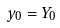<formula> <loc_0><loc_0><loc_500><loc_500>y _ { 0 } = Y _ { 0 }</formula> 